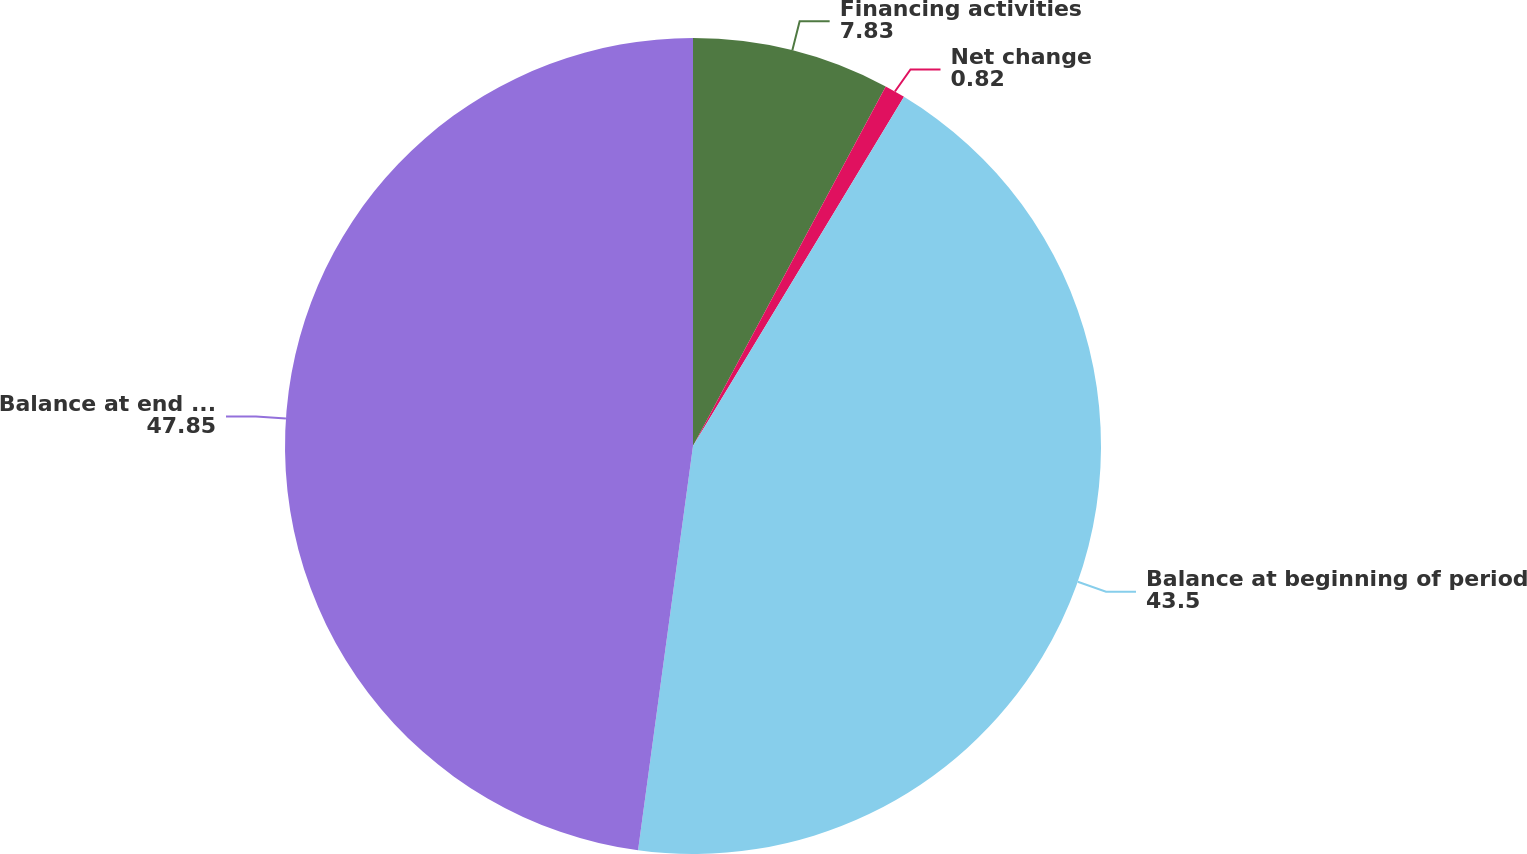<chart> <loc_0><loc_0><loc_500><loc_500><pie_chart><fcel>Financing activities<fcel>Net change<fcel>Balance at beginning of period<fcel>Balance at end of period<nl><fcel>7.83%<fcel>0.82%<fcel>43.5%<fcel>47.85%<nl></chart> 